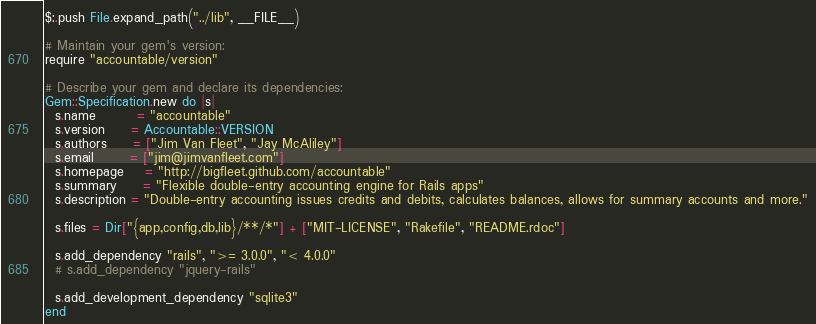<code> <loc_0><loc_0><loc_500><loc_500><_Ruby_>$:.push File.expand_path("../lib", __FILE__)

# Maintain your gem's version:
require "accountable/version"

# Describe your gem and declare its dependencies:
Gem::Specification.new do |s|
  s.name        = "accountable"
  s.version     = Accountable::VERSION
  s.authors     = ["Jim Van Fleet", "Jay McAliley"]
  s.email       = ["jim@jimvanfleet.com"]
  s.homepage    = "http://bigfleet.github.com/accountable"
  s.summary     = "Flexible double-entry accounting engine for Rails apps"
  s.description = "Double-entry accounting issues credits and debits, calculates balances, allows for summary accounts and more."

  s.files = Dir["{app,config,db,lib}/**/*"] + ["MIT-LICENSE", "Rakefile", "README.rdoc"]

  s.add_dependency "rails", ">= 3.0.0", "< 4.0.0"
  # s.add_dependency "jquery-rails"

  s.add_development_dependency "sqlite3"
end
</code> 